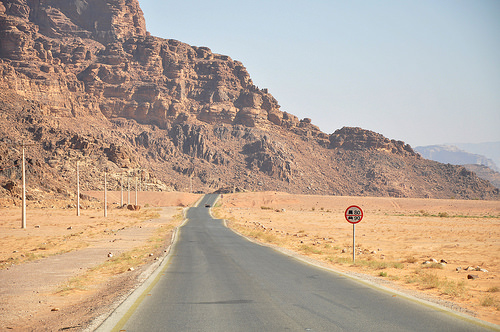<image>
Is the sign on the road? No. The sign is not positioned on the road. They may be near each other, but the sign is not supported by or resting on top of the road. 